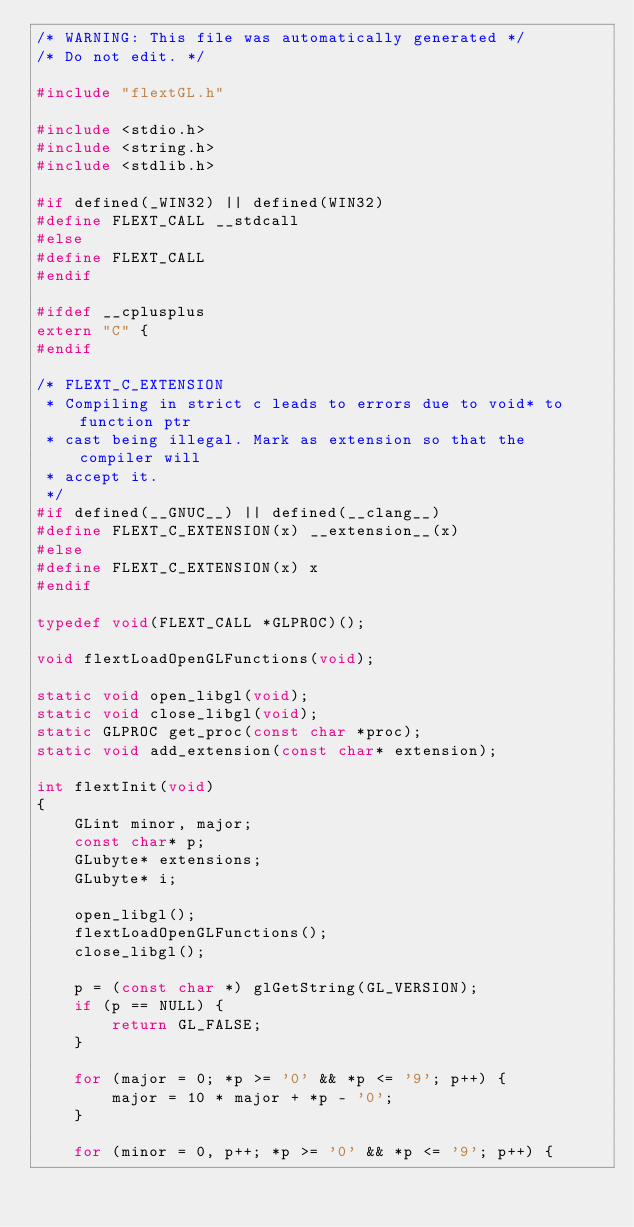Convert code to text. <code><loc_0><loc_0><loc_500><loc_500><_C_>/* WARNING: This file was automatically generated */
/* Do not edit. */

#include "flextGL.h"

#include <stdio.h>
#include <string.h>
#include <stdlib.h>

#if defined(_WIN32) || defined(WIN32)
#define FLEXT_CALL __stdcall
#else
#define FLEXT_CALL
#endif

#ifdef __cplusplus
extern "C" {
#endif

/* FLEXT_C_EXTENSION
 * Compiling in strict c leads to errors due to void* to function ptr
 * cast being illegal. Mark as extension so that the compiler will
 * accept it.
 */
#if defined(__GNUC__) || defined(__clang__)
#define FLEXT_C_EXTENSION(x) __extension__(x)
#else
#define FLEXT_C_EXTENSION(x) x
#endif

typedef void(FLEXT_CALL *GLPROC)();

void flextLoadOpenGLFunctions(void);

static void open_libgl(void);
static void close_libgl(void);
static GLPROC get_proc(const char *proc);
static void add_extension(const char* extension);

int flextInit(void)
{
    GLint minor, major;
    const char* p;
    GLubyte* extensions;
    GLubyte* i;

    open_libgl();
    flextLoadOpenGLFunctions();
    close_libgl();

    p = (const char *) glGetString(GL_VERSION);
    if (p == NULL) {
        return GL_FALSE;
    }

    for (major = 0; *p >= '0' && *p <= '9'; p++) {
        major = 10 * major + *p - '0';
    }

    for (minor = 0, p++; *p >= '0' && *p <= '9'; p++) {</code> 